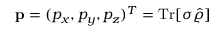<formula> <loc_0><loc_0><loc_500><loc_500>{ p } = ( p _ { x } , p _ { y } , p _ { z } ) ^ { T } = T r [ \sigma \hat { \varrho } ]</formula> 